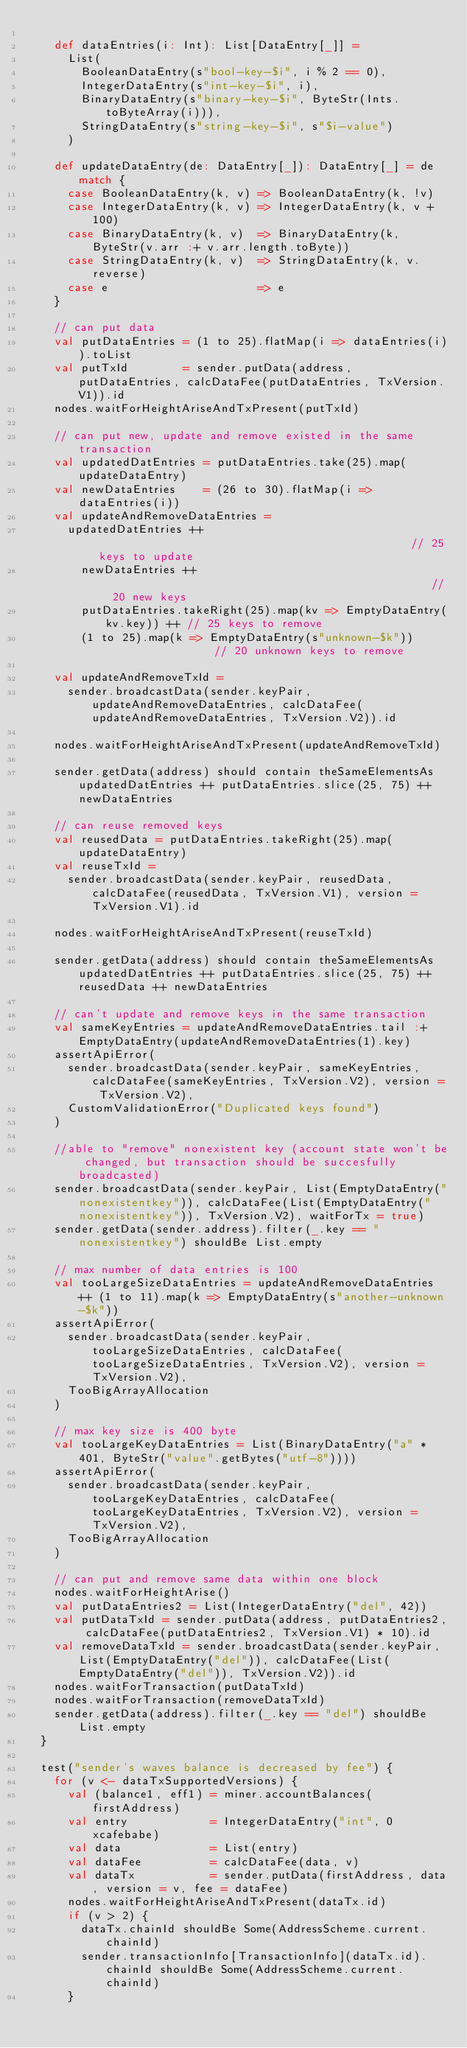<code> <loc_0><loc_0><loc_500><loc_500><_Scala_>
    def dataEntries(i: Int): List[DataEntry[_]] =
      List(
        BooleanDataEntry(s"bool-key-$i", i % 2 == 0),
        IntegerDataEntry(s"int-key-$i", i),
        BinaryDataEntry(s"binary-key-$i", ByteStr(Ints.toByteArray(i))),
        StringDataEntry(s"string-key-$i", s"$i-value")
      )

    def updateDataEntry(de: DataEntry[_]): DataEntry[_] = de match {
      case BooleanDataEntry(k, v) => BooleanDataEntry(k, !v)
      case IntegerDataEntry(k, v) => IntegerDataEntry(k, v + 100)
      case BinaryDataEntry(k, v)  => BinaryDataEntry(k, ByteStr(v.arr :+ v.arr.length.toByte))
      case StringDataEntry(k, v)  => StringDataEntry(k, v.reverse)
      case e                      => e
    }

    // can put data
    val putDataEntries = (1 to 25).flatMap(i => dataEntries(i)).toList
    val putTxId        = sender.putData(address, putDataEntries, calcDataFee(putDataEntries, TxVersion.V1)).id
    nodes.waitForHeightAriseAndTxPresent(putTxId)

    // can put new, update and remove existed in the same transaction
    val updatedDatEntries = putDataEntries.take(25).map(updateDataEntry)
    val newDataEntries    = (26 to 30).flatMap(i => dataEntries(i))
    val updateAndRemoveDataEntries =
      updatedDatEntries ++                                                // 25 keys to update
        newDataEntries ++                                                 // 20 new keys
        putDataEntries.takeRight(25).map(kv => EmptyDataEntry(kv.key)) ++ // 25 keys to remove
        (1 to 25).map(k => EmptyDataEntry(s"unknown-$k"))                 // 20 unknown keys to remove

    val updateAndRemoveTxId =
      sender.broadcastData(sender.keyPair, updateAndRemoveDataEntries, calcDataFee(updateAndRemoveDataEntries, TxVersion.V2)).id

    nodes.waitForHeightAriseAndTxPresent(updateAndRemoveTxId)

    sender.getData(address) should contain theSameElementsAs updatedDatEntries ++ putDataEntries.slice(25, 75) ++ newDataEntries

    // can reuse removed keys
    val reusedData = putDataEntries.takeRight(25).map(updateDataEntry)
    val reuseTxId =
      sender.broadcastData(sender.keyPair, reusedData, calcDataFee(reusedData, TxVersion.V1), version = TxVersion.V1).id

    nodes.waitForHeightAriseAndTxPresent(reuseTxId)

    sender.getData(address) should contain theSameElementsAs updatedDatEntries ++ putDataEntries.slice(25, 75) ++ reusedData ++ newDataEntries

    // can't update and remove keys in the same transaction
    val sameKeyEntries = updateAndRemoveDataEntries.tail :+ EmptyDataEntry(updateAndRemoveDataEntries(1).key)
    assertApiError(
      sender.broadcastData(sender.keyPair, sameKeyEntries, calcDataFee(sameKeyEntries, TxVersion.V2), version = TxVersion.V2),
      CustomValidationError("Duplicated keys found")
    )

    //able to "remove" nonexistent key (account state won't be changed, but transaction should be succesfully broadcasted)
    sender.broadcastData(sender.keyPair, List(EmptyDataEntry("nonexistentkey")), calcDataFee(List(EmptyDataEntry("nonexistentkey")), TxVersion.V2), waitForTx = true)
    sender.getData(sender.address).filter(_.key == "nonexistentkey") shouldBe List.empty

    // max number of data entries is 100
    val tooLargeSizeDataEntries = updateAndRemoveDataEntries ++ (1 to 11).map(k => EmptyDataEntry(s"another-unknown-$k"))
    assertApiError(
      sender.broadcastData(sender.keyPair, tooLargeSizeDataEntries, calcDataFee(tooLargeSizeDataEntries, TxVersion.V2), version = TxVersion.V2),
      TooBigArrayAllocation
    )

    // max key size is 400 byte
    val tooLargeKeyDataEntries = List(BinaryDataEntry("a" * 401, ByteStr("value".getBytes("utf-8"))))
    assertApiError(
      sender.broadcastData(sender.keyPair, tooLargeKeyDataEntries, calcDataFee(tooLargeKeyDataEntries, TxVersion.V2), version = TxVersion.V2),
      TooBigArrayAllocation
    )

    // can put and remove same data within one block
    nodes.waitForHeightArise()
    val putDataEntries2 = List(IntegerDataEntry("del", 42))
    val putDataTxId = sender.putData(address, putDataEntries2, calcDataFee(putDataEntries2, TxVersion.V1) * 10).id
    val removeDataTxId = sender.broadcastData(sender.keyPair, List(EmptyDataEntry("del")), calcDataFee(List(EmptyDataEntry("del")), TxVersion.V2)).id
    nodes.waitForTransaction(putDataTxId)
    nodes.waitForTransaction(removeDataTxId)
    sender.getData(address).filter(_.key == "del") shouldBe List.empty
  }

  test("sender's waves balance is decreased by fee") {
    for (v <- dataTxSupportedVersions) {
      val (balance1, eff1) = miner.accountBalances(firstAddress)
      val entry            = IntegerDataEntry("int", 0xcafebabe)
      val data             = List(entry)
      val dataFee          = calcDataFee(data, v)
      val dataTx           = sender.putData(firstAddress, data, version = v, fee = dataFee)
      nodes.waitForHeightAriseAndTxPresent(dataTx.id)
      if (v > 2) {
        dataTx.chainId shouldBe Some(AddressScheme.current.chainId)
        sender.transactionInfo[TransactionInfo](dataTx.id).chainId shouldBe Some(AddressScheme.current.chainId)
      }</code> 